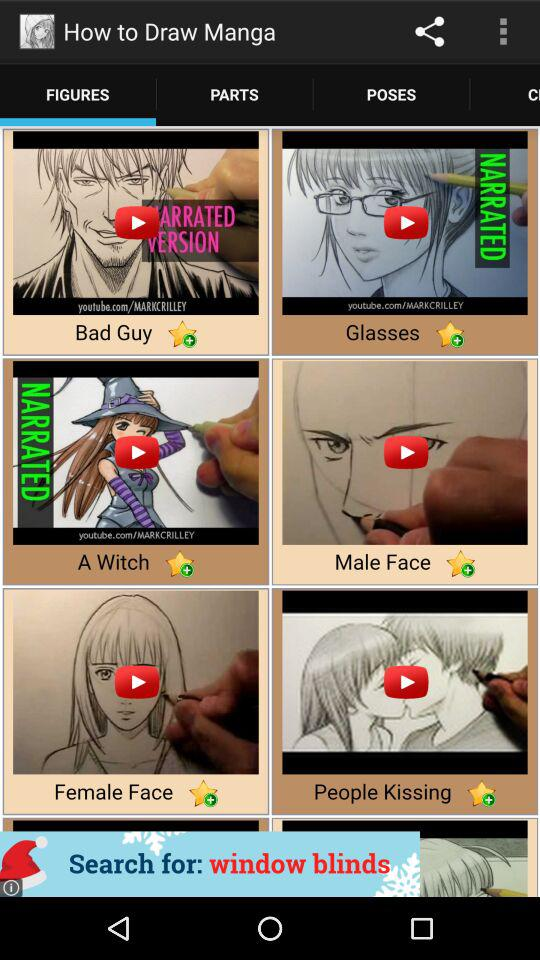On what tab am I on now? You are on "FIGURES" tab. 